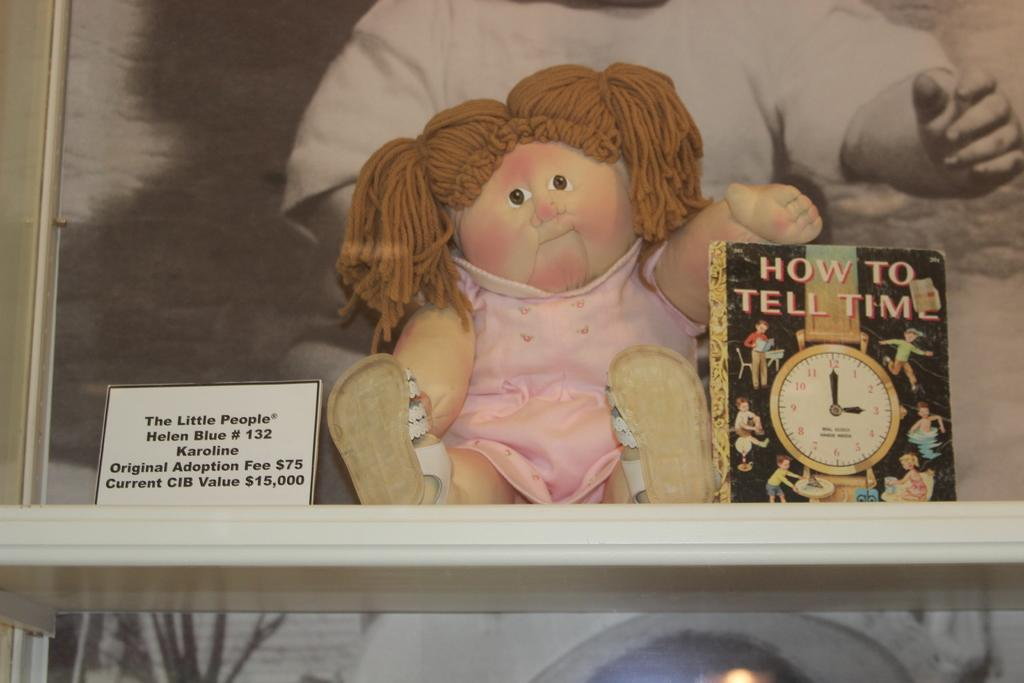<image>
Present a compact description of the photo's key features. A doll sitting next to a book called How to Tell Time 